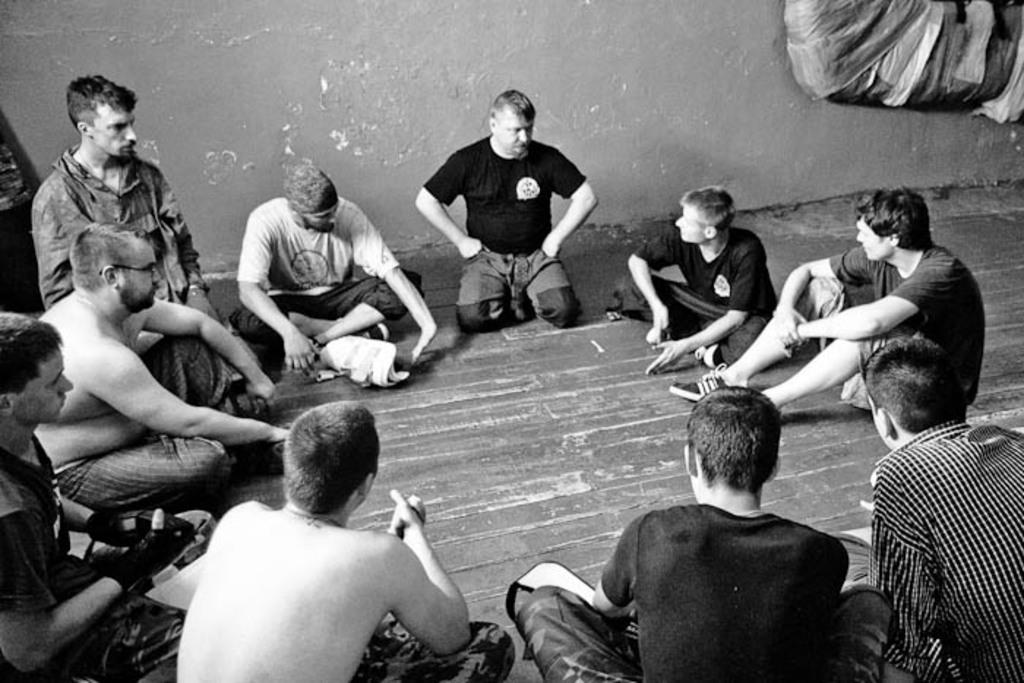What is the primary activity of the men in the image? The men in the image are sitting on the floor. Can you describe the setting in which the men are sitting? There is a wall visible in the background of the image. What is the name of the operation being performed by the men in the image? There is no operation being performed by the men in the image; they are simply sitting on the floor. Can you tell me where the sink is located in the image? There is no sink present in the image. 